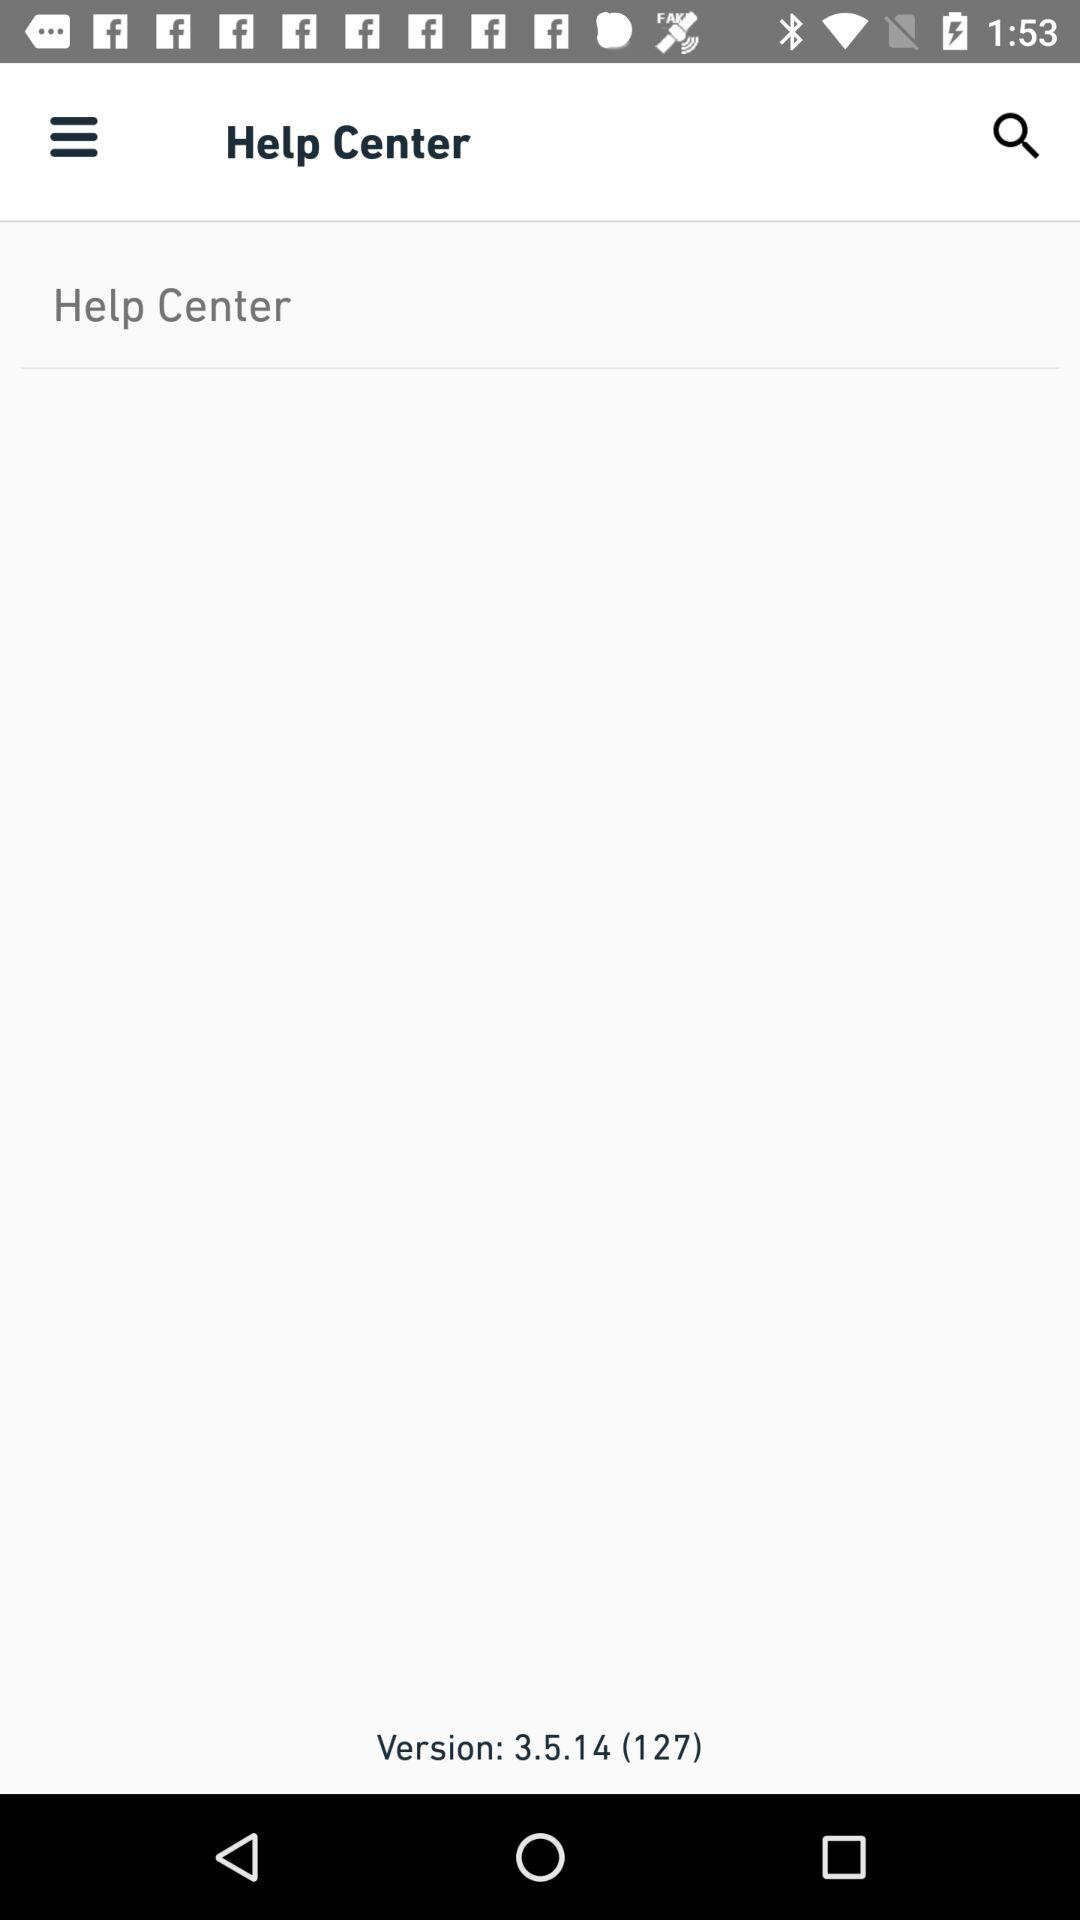What version is it? The version is 3.5.14 (127). 